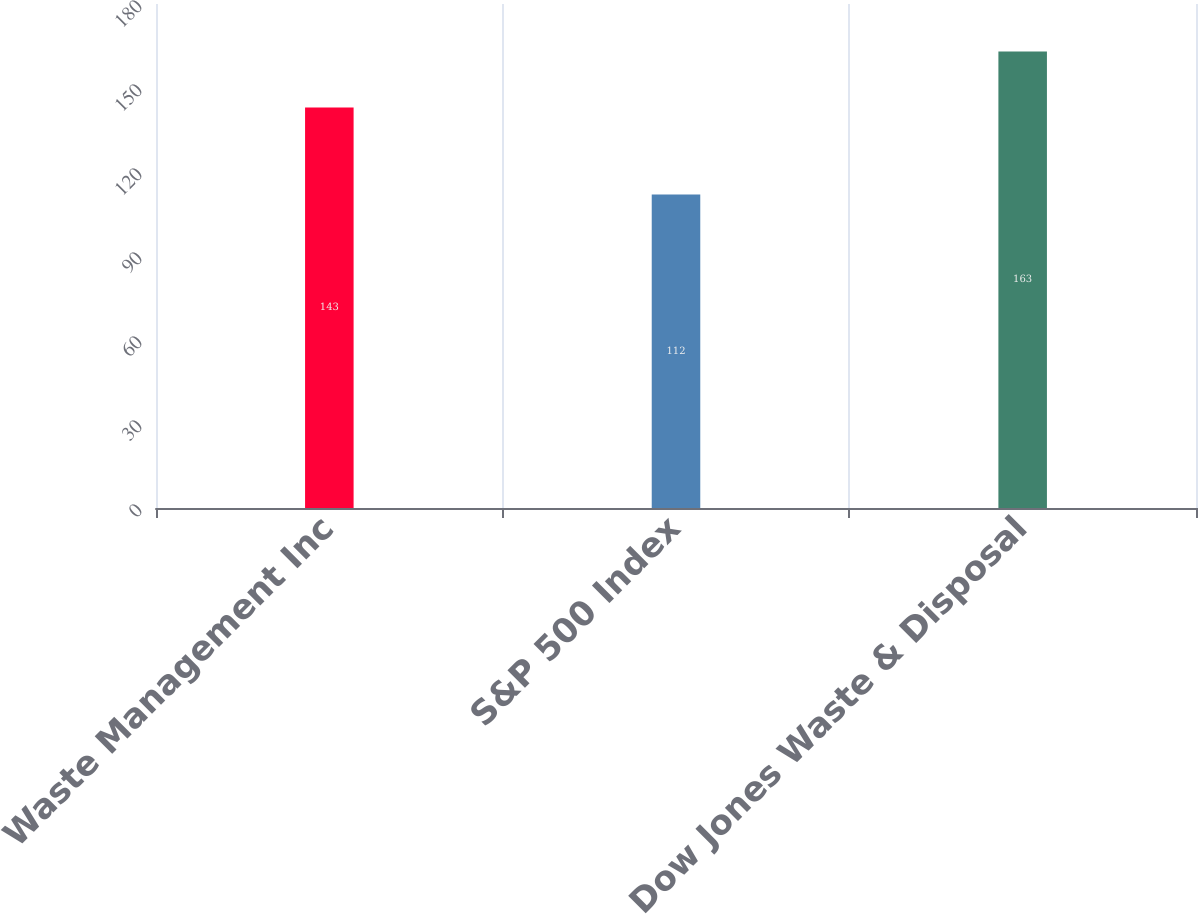Convert chart to OTSL. <chart><loc_0><loc_0><loc_500><loc_500><bar_chart><fcel>Waste Management Inc<fcel>S&P 500 Index<fcel>Dow Jones Waste & Disposal<nl><fcel>143<fcel>112<fcel>163<nl></chart> 